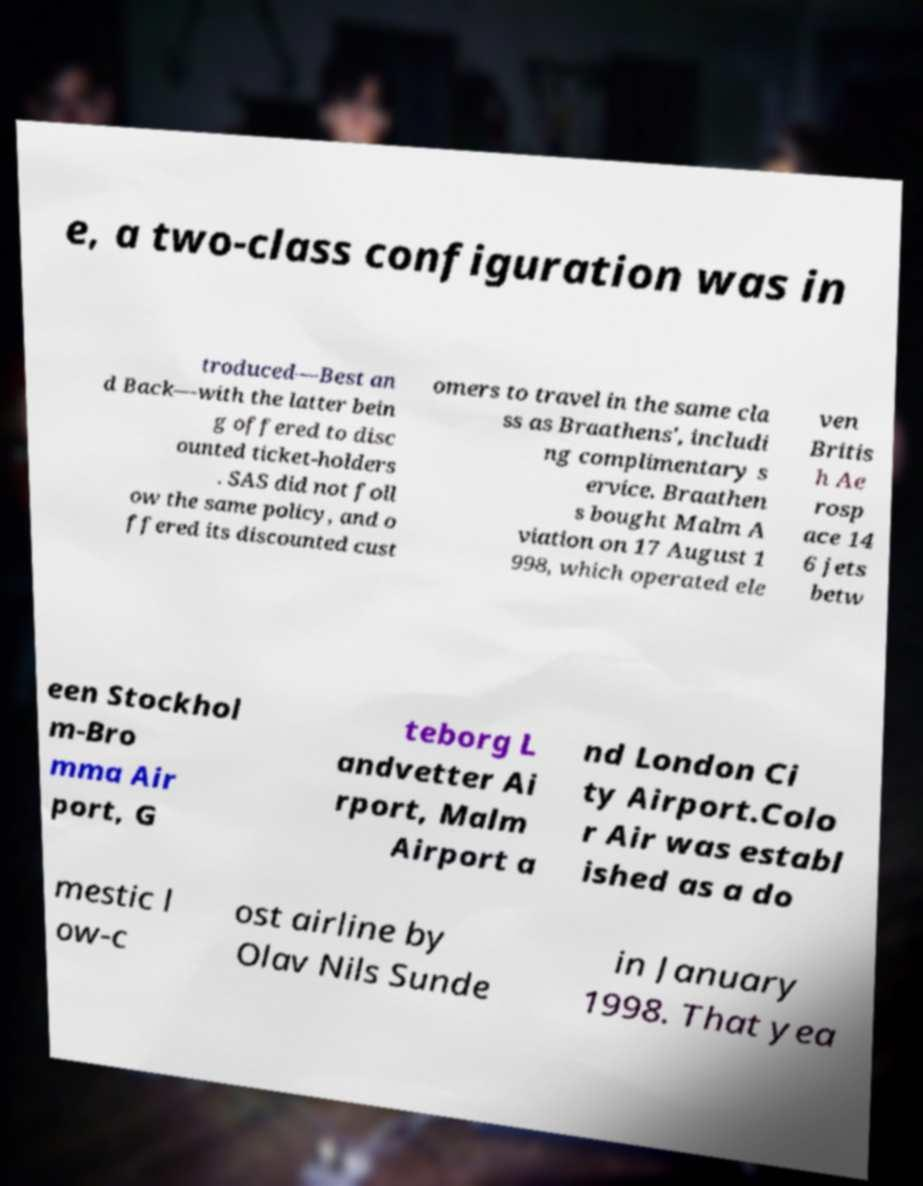Can you accurately transcribe the text from the provided image for me? e, a two-class configuration was in troduced—Best an d Back—with the latter bein g offered to disc ounted ticket-holders . SAS did not foll ow the same policy, and o ffered its discounted cust omers to travel in the same cla ss as Braathens', includi ng complimentary s ervice. Braathen s bought Malm A viation on 17 August 1 998, which operated ele ven Britis h Ae rosp ace 14 6 jets betw een Stockhol m-Bro mma Air port, G teborg L andvetter Ai rport, Malm Airport a nd London Ci ty Airport.Colo r Air was establ ished as a do mestic l ow-c ost airline by Olav Nils Sunde in January 1998. That yea 